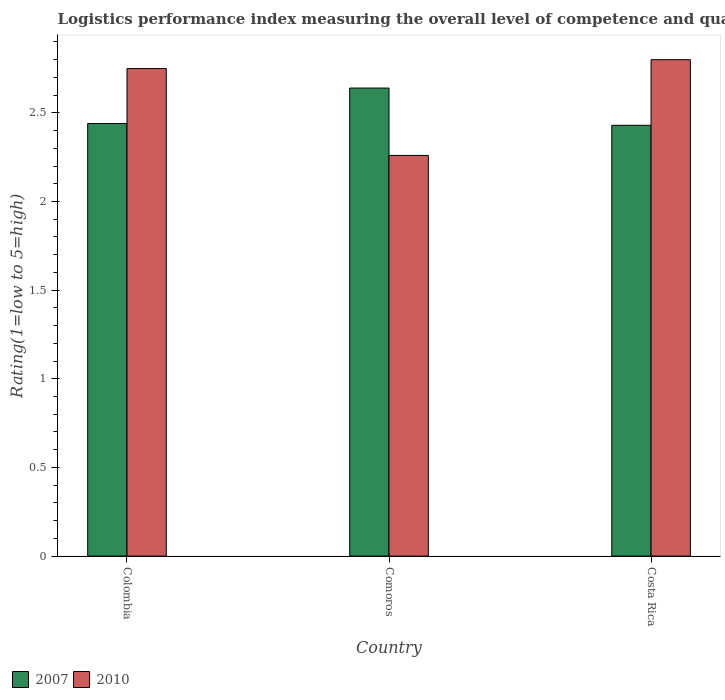Are the number of bars on each tick of the X-axis equal?
Give a very brief answer. Yes. How many bars are there on the 2nd tick from the left?
Your answer should be very brief. 2. How many bars are there on the 1st tick from the right?
Provide a short and direct response. 2. What is the label of the 1st group of bars from the left?
Your response must be concise. Colombia. What is the Logistic performance index in 2010 in Comoros?
Ensure brevity in your answer.  2.26. Across all countries, what is the minimum Logistic performance index in 2010?
Your response must be concise. 2.26. In which country was the Logistic performance index in 2007 maximum?
Provide a succinct answer. Comoros. In which country was the Logistic performance index in 2007 minimum?
Keep it short and to the point. Costa Rica. What is the total Logistic performance index in 2007 in the graph?
Make the answer very short. 7.51. What is the difference between the Logistic performance index in 2010 in Comoros and that in Costa Rica?
Provide a short and direct response. -0.54. What is the difference between the Logistic performance index in 2010 in Comoros and the Logistic performance index in 2007 in Colombia?
Provide a short and direct response. -0.18. What is the average Logistic performance index in 2010 per country?
Give a very brief answer. 2.6. What is the difference between the Logistic performance index of/in 2010 and Logistic performance index of/in 2007 in Comoros?
Make the answer very short. -0.38. In how many countries, is the Logistic performance index in 2010 greater than 2.7?
Offer a terse response. 2. What is the ratio of the Logistic performance index in 2010 in Colombia to that in Comoros?
Provide a short and direct response. 1.22. Is the difference between the Logistic performance index in 2010 in Colombia and Comoros greater than the difference between the Logistic performance index in 2007 in Colombia and Comoros?
Offer a terse response. Yes. What is the difference between the highest and the second highest Logistic performance index in 2010?
Your response must be concise. 0.05. What is the difference between the highest and the lowest Logistic performance index in 2010?
Keep it short and to the point. 0.54. In how many countries, is the Logistic performance index in 2007 greater than the average Logistic performance index in 2007 taken over all countries?
Ensure brevity in your answer.  1. What does the 2nd bar from the left in Colombia represents?
Provide a short and direct response. 2010. Are all the bars in the graph horizontal?
Your answer should be compact. No. How many countries are there in the graph?
Your response must be concise. 3. What is the difference between two consecutive major ticks on the Y-axis?
Provide a succinct answer. 0.5. Where does the legend appear in the graph?
Your answer should be compact. Bottom left. How many legend labels are there?
Provide a succinct answer. 2. How are the legend labels stacked?
Give a very brief answer. Horizontal. What is the title of the graph?
Provide a succinct answer. Logistics performance index measuring the overall level of competence and quality of logistics services. What is the label or title of the X-axis?
Provide a succinct answer. Country. What is the label or title of the Y-axis?
Offer a terse response. Rating(1=low to 5=high). What is the Rating(1=low to 5=high) in 2007 in Colombia?
Your answer should be very brief. 2.44. What is the Rating(1=low to 5=high) in 2010 in Colombia?
Your response must be concise. 2.75. What is the Rating(1=low to 5=high) of 2007 in Comoros?
Ensure brevity in your answer.  2.64. What is the Rating(1=low to 5=high) in 2010 in Comoros?
Provide a succinct answer. 2.26. What is the Rating(1=low to 5=high) of 2007 in Costa Rica?
Your answer should be very brief. 2.43. Across all countries, what is the maximum Rating(1=low to 5=high) in 2007?
Your answer should be very brief. 2.64. Across all countries, what is the maximum Rating(1=low to 5=high) of 2010?
Keep it short and to the point. 2.8. Across all countries, what is the minimum Rating(1=low to 5=high) in 2007?
Offer a very short reply. 2.43. Across all countries, what is the minimum Rating(1=low to 5=high) of 2010?
Keep it short and to the point. 2.26. What is the total Rating(1=low to 5=high) in 2007 in the graph?
Make the answer very short. 7.51. What is the total Rating(1=low to 5=high) in 2010 in the graph?
Give a very brief answer. 7.81. What is the difference between the Rating(1=low to 5=high) in 2007 in Colombia and that in Comoros?
Provide a succinct answer. -0.2. What is the difference between the Rating(1=low to 5=high) of 2010 in Colombia and that in Comoros?
Your response must be concise. 0.49. What is the difference between the Rating(1=low to 5=high) in 2007 in Colombia and that in Costa Rica?
Your answer should be very brief. 0.01. What is the difference between the Rating(1=low to 5=high) in 2010 in Colombia and that in Costa Rica?
Give a very brief answer. -0.05. What is the difference between the Rating(1=low to 5=high) in 2007 in Comoros and that in Costa Rica?
Offer a terse response. 0.21. What is the difference between the Rating(1=low to 5=high) in 2010 in Comoros and that in Costa Rica?
Your answer should be very brief. -0.54. What is the difference between the Rating(1=low to 5=high) in 2007 in Colombia and the Rating(1=low to 5=high) in 2010 in Comoros?
Your response must be concise. 0.18. What is the difference between the Rating(1=low to 5=high) in 2007 in Colombia and the Rating(1=low to 5=high) in 2010 in Costa Rica?
Provide a succinct answer. -0.36. What is the difference between the Rating(1=low to 5=high) of 2007 in Comoros and the Rating(1=low to 5=high) of 2010 in Costa Rica?
Your response must be concise. -0.16. What is the average Rating(1=low to 5=high) in 2007 per country?
Your response must be concise. 2.5. What is the average Rating(1=low to 5=high) in 2010 per country?
Your answer should be compact. 2.6. What is the difference between the Rating(1=low to 5=high) in 2007 and Rating(1=low to 5=high) in 2010 in Colombia?
Make the answer very short. -0.31. What is the difference between the Rating(1=low to 5=high) in 2007 and Rating(1=low to 5=high) in 2010 in Comoros?
Give a very brief answer. 0.38. What is the difference between the Rating(1=low to 5=high) of 2007 and Rating(1=low to 5=high) of 2010 in Costa Rica?
Your answer should be very brief. -0.37. What is the ratio of the Rating(1=low to 5=high) of 2007 in Colombia to that in Comoros?
Your answer should be compact. 0.92. What is the ratio of the Rating(1=low to 5=high) of 2010 in Colombia to that in Comoros?
Make the answer very short. 1.22. What is the ratio of the Rating(1=low to 5=high) in 2007 in Colombia to that in Costa Rica?
Provide a short and direct response. 1. What is the ratio of the Rating(1=low to 5=high) in 2010 in Colombia to that in Costa Rica?
Provide a short and direct response. 0.98. What is the ratio of the Rating(1=low to 5=high) of 2007 in Comoros to that in Costa Rica?
Give a very brief answer. 1.09. What is the ratio of the Rating(1=low to 5=high) in 2010 in Comoros to that in Costa Rica?
Make the answer very short. 0.81. What is the difference between the highest and the second highest Rating(1=low to 5=high) in 2007?
Your answer should be very brief. 0.2. What is the difference between the highest and the second highest Rating(1=low to 5=high) of 2010?
Offer a terse response. 0.05. What is the difference between the highest and the lowest Rating(1=low to 5=high) in 2007?
Give a very brief answer. 0.21. What is the difference between the highest and the lowest Rating(1=low to 5=high) in 2010?
Your answer should be very brief. 0.54. 